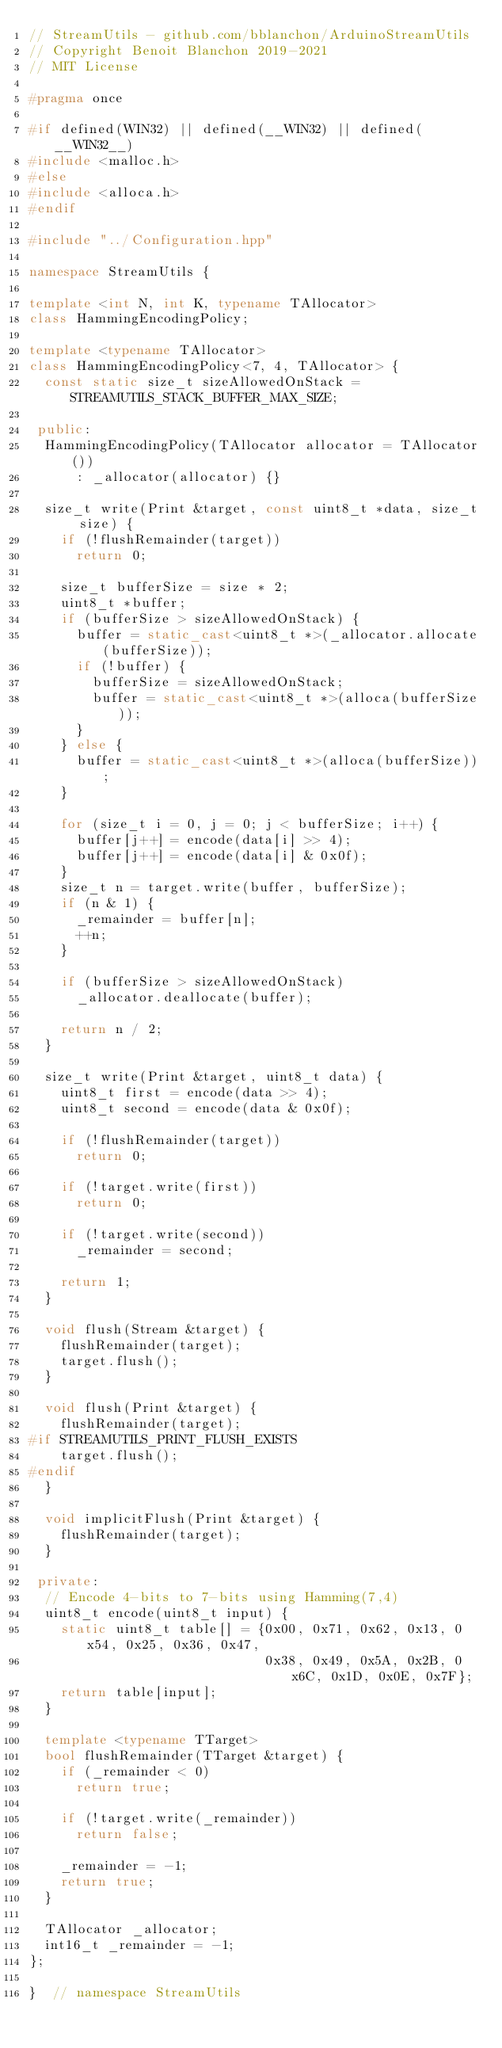<code> <loc_0><loc_0><loc_500><loc_500><_C++_>// StreamUtils - github.com/bblanchon/ArduinoStreamUtils
// Copyright Benoit Blanchon 2019-2021
// MIT License

#pragma once

#if defined(WIN32) || defined(__WIN32) || defined(__WIN32__)
#include <malloc.h>
#else
#include <alloca.h>
#endif

#include "../Configuration.hpp"

namespace StreamUtils {

template <int N, int K, typename TAllocator>
class HammingEncodingPolicy;

template <typename TAllocator>
class HammingEncodingPolicy<7, 4, TAllocator> {
  const static size_t sizeAllowedOnStack = STREAMUTILS_STACK_BUFFER_MAX_SIZE;

 public:
  HammingEncodingPolicy(TAllocator allocator = TAllocator())
      : _allocator(allocator) {}

  size_t write(Print &target, const uint8_t *data, size_t size) {
    if (!flushRemainder(target))
      return 0;

    size_t bufferSize = size * 2;
    uint8_t *buffer;
    if (bufferSize > sizeAllowedOnStack) {
      buffer = static_cast<uint8_t *>(_allocator.allocate(bufferSize));
      if (!buffer) {
        bufferSize = sizeAllowedOnStack;
        buffer = static_cast<uint8_t *>(alloca(bufferSize));
      }
    } else {
      buffer = static_cast<uint8_t *>(alloca(bufferSize));
    }

    for (size_t i = 0, j = 0; j < bufferSize; i++) {
      buffer[j++] = encode(data[i] >> 4);
      buffer[j++] = encode(data[i] & 0x0f);
    }
    size_t n = target.write(buffer, bufferSize);
    if (n & 1) {
      _remainder = buffer[n];
      ++n;
    }

    if (bufferSize > sizeAllowedOnStack)
      _allocator.deallocate(buffer);

    return n / 2;
  }

  size_t write(Print &target, uint8_t data) {
    uint8_t first = encode(data >> 4);
    uint8_t second = encode(data & 0x0f);

    if (!flushRemainder(target))
      return 0;

    if (!target.write(first))
      return 0;

    if (!target.write(second))
      _remainder = second;

    return 1;
  }

  void flush(Stream &target) {
    flushRemainder(target);
    target.flush();
  }

  void flush(Print &target) {
    flushRemainder(target);
#if STREAMUTILS_PRINT_FLUSH_EXISTS
    target.flush();
#endif
  }

  void implicitFlush(Print &target) {
    flushRemainder(target);
  }

 private:
  // Encode 4-bits to 7-bits using Hamming(7,4)
  uint8_t encode(uint8_t input) {
    static uint8_t table[] = {0x00, 0x71, 0x62, 0x13, 0x54, 0x25, 0x36, 0x47,
                              0x38, 0x49, 0x5A, 0x2B, 0x6C, 0x1D, 0x0E, 0x7F};
    return table[input];
  }

  template <typename TTarget>
  bool flushRemainder(TTarget &target) {
    if (_remainder < 0)
      return true;

    if (!target.write(_remainder))
      return false;

    _remainder = -1;
    return true;
  }

  TAllocator _allocator;
  int16_t _remainder = -1;
};

}  // namespace StreamUtils</code> 